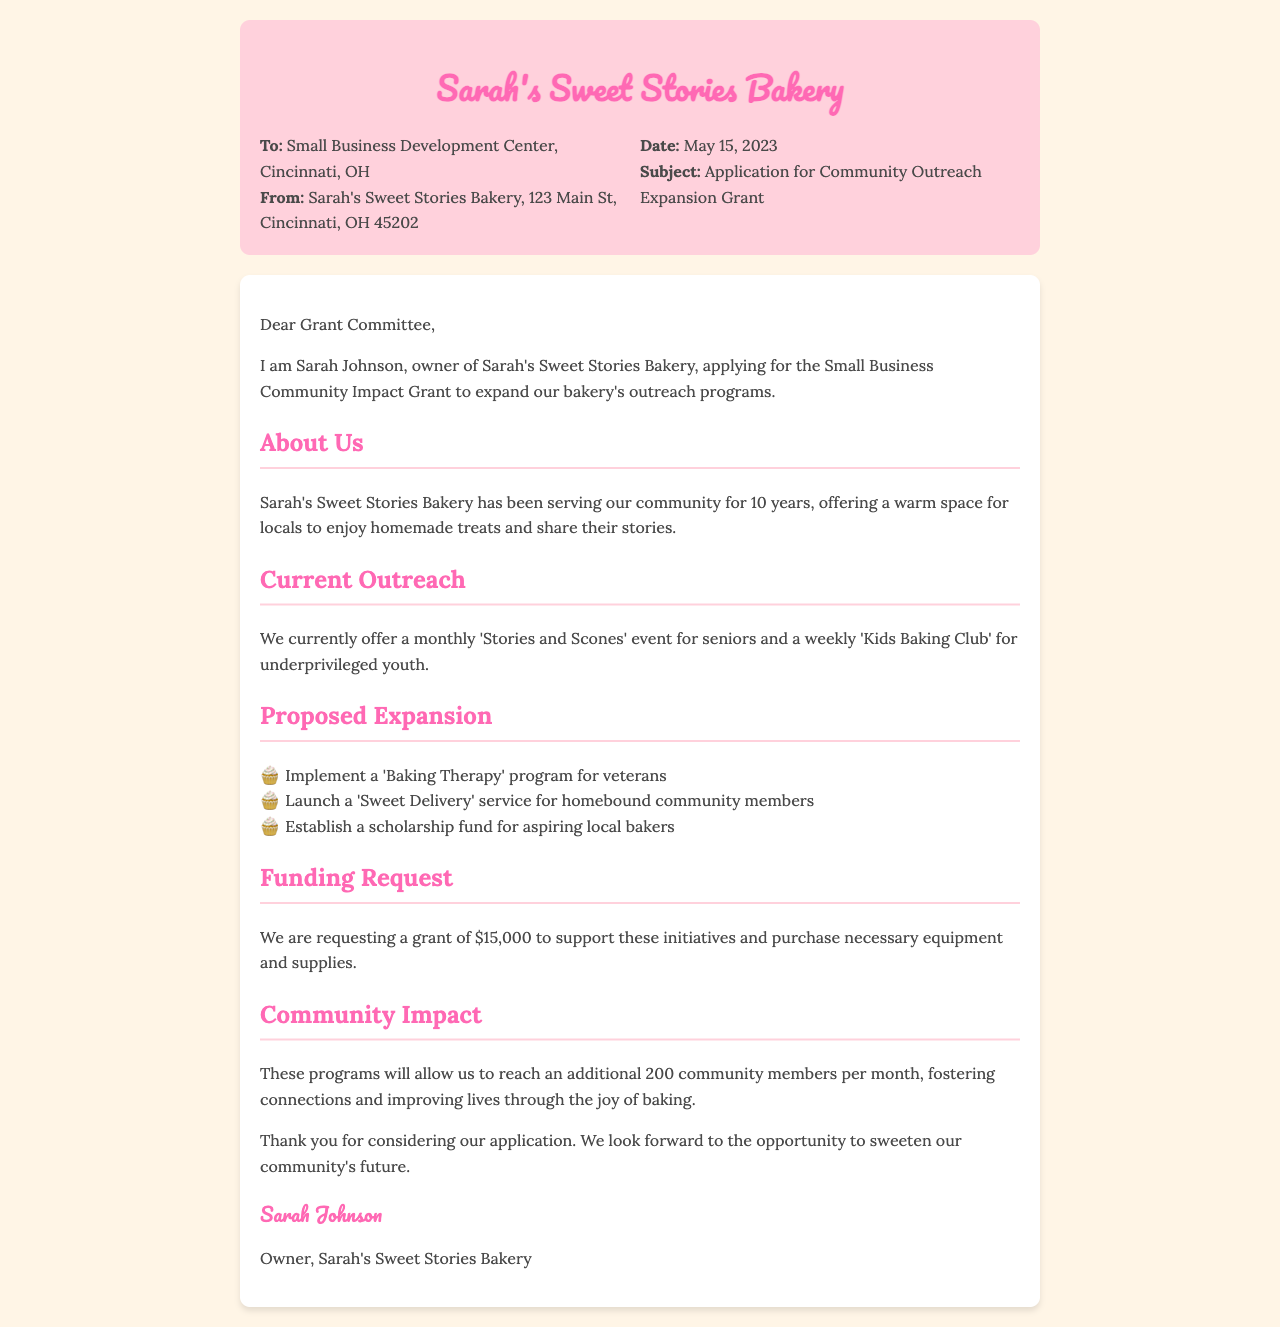What is the name of the bakery? The bakery is named "Sarah's Sweet Stories Bakery," as stated in the document's header.
Answer: Sarah's Sweet Stories Bakery Who is the owner of the bakery? The application states that Sarah Johnson is the owner of the bakery.
Answer: Sarah Johnson What is the date of the fax? The document provides the date as May 15, 2023, in the header section.
Answer: May 15, 2023 How much funding is being requested? The funding request mentioned in the document is for $15,000 to support the proposed initiatives.
Answer: $15,000 What is one current outreach program mentioned? The document lists the "Stories and Scones" event for seniors as one current outreach program.
Answer: Stories and Scones What is the purpose of the proposed 'Baking Therapy' program? The program is intended for veterans, aiming to provide therapeutic baking opportunities.
Answer: veterans How many community members will the new programs reach each month? The document states that the new programs will allow the bakery to reach an additional 200 community members per month.
Answer: 200 What is the primary goal of expanding the outreach programs? The goal is to foster connections and improve lives through the joy of baking, as noted in the community impact section.
Answer: connections What is the organization the application is addressed to? The application is directed to the Small Business Development Center in Cincinnati, OH, which is noted in the header.
Answer: Small Business Development Center 